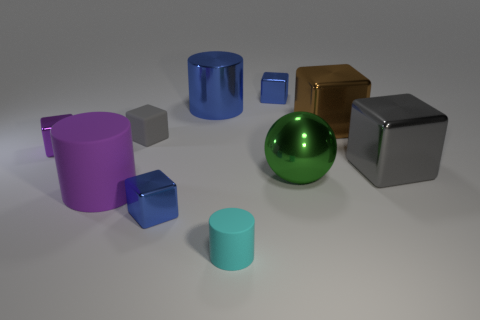Subtract all big rubber cylinders. How many cylinders are left? 2 Subtract 1 spheres. How many spheres are left? 0 Subtract all blue blocks. How many blocks are left? 4 Subtract all spheres. How many objects are left? 9 Subtract all red cubes. Subtract all yellow spheres. How many cubes are left? 6 Subtract all blue cylinders. How many brown cubes are left? 1 Subtract all big blue rubber cubes. Subtract all big blue shiny cylinders. How many objects are left? 9 Add 7 gray things. How many gray things are left? 9 Add 5 gray matte blocks. How many gray matte blocks exist? 6 Subtract 0 green blocks. How many objects are left? 10 